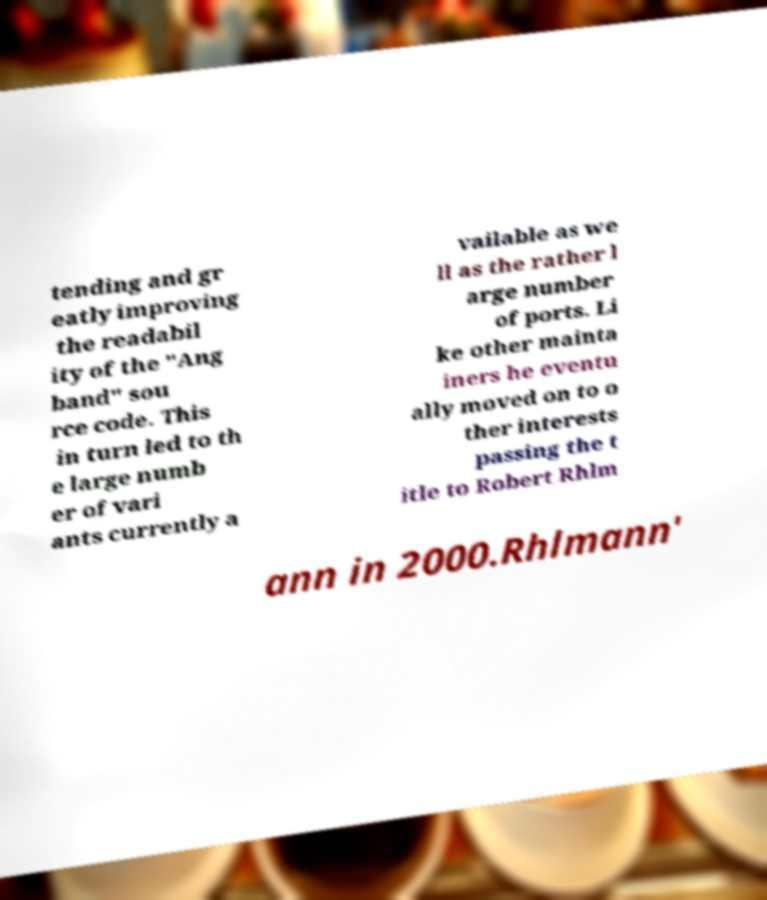I need the written content from this picture converted into text. Can you do that? tending and gr eatly improving the readabil ity of the "Ang band" sou rce code. This in turn led to th e large numb er of vari ants currently a vailable as we ll as the rather l arge number of ports. Li ke other mainta iners he eventu ally moved on to o ther interests passing the t itle to Robert Rhlm ann in 2000.Rhlmann' 